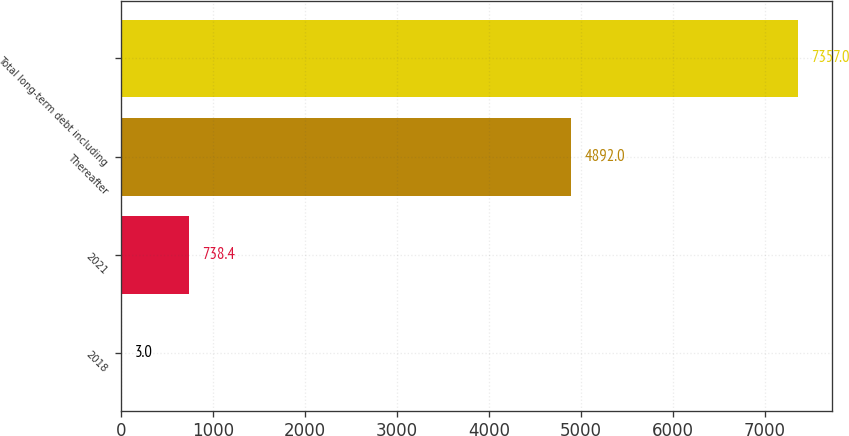Convert chart to OTSL. <chart><loc_0><loc_0><loc_500><loc_500><bar_chart><fcel>2018<fcel>2021<fcel>Thereafter<fcel>Total long-term debt including<nl><fcel>3<fcel>738.4<fcel>4892<fcel>7357<nl></chart> 